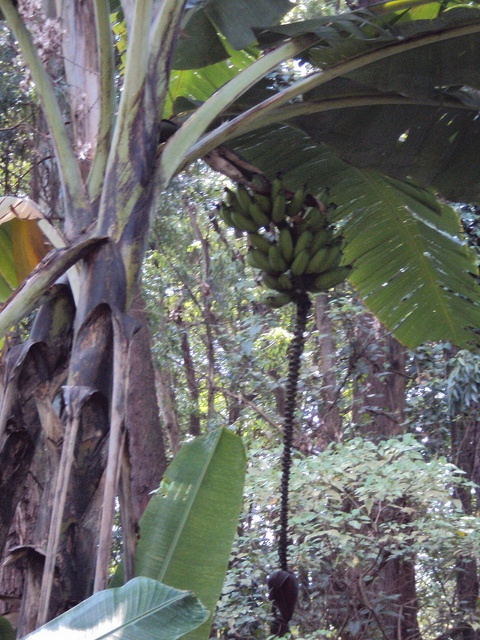Describe the objects in this image and their specific colors. I can see a banana in gray, black, and darkgreen tones in this image. 